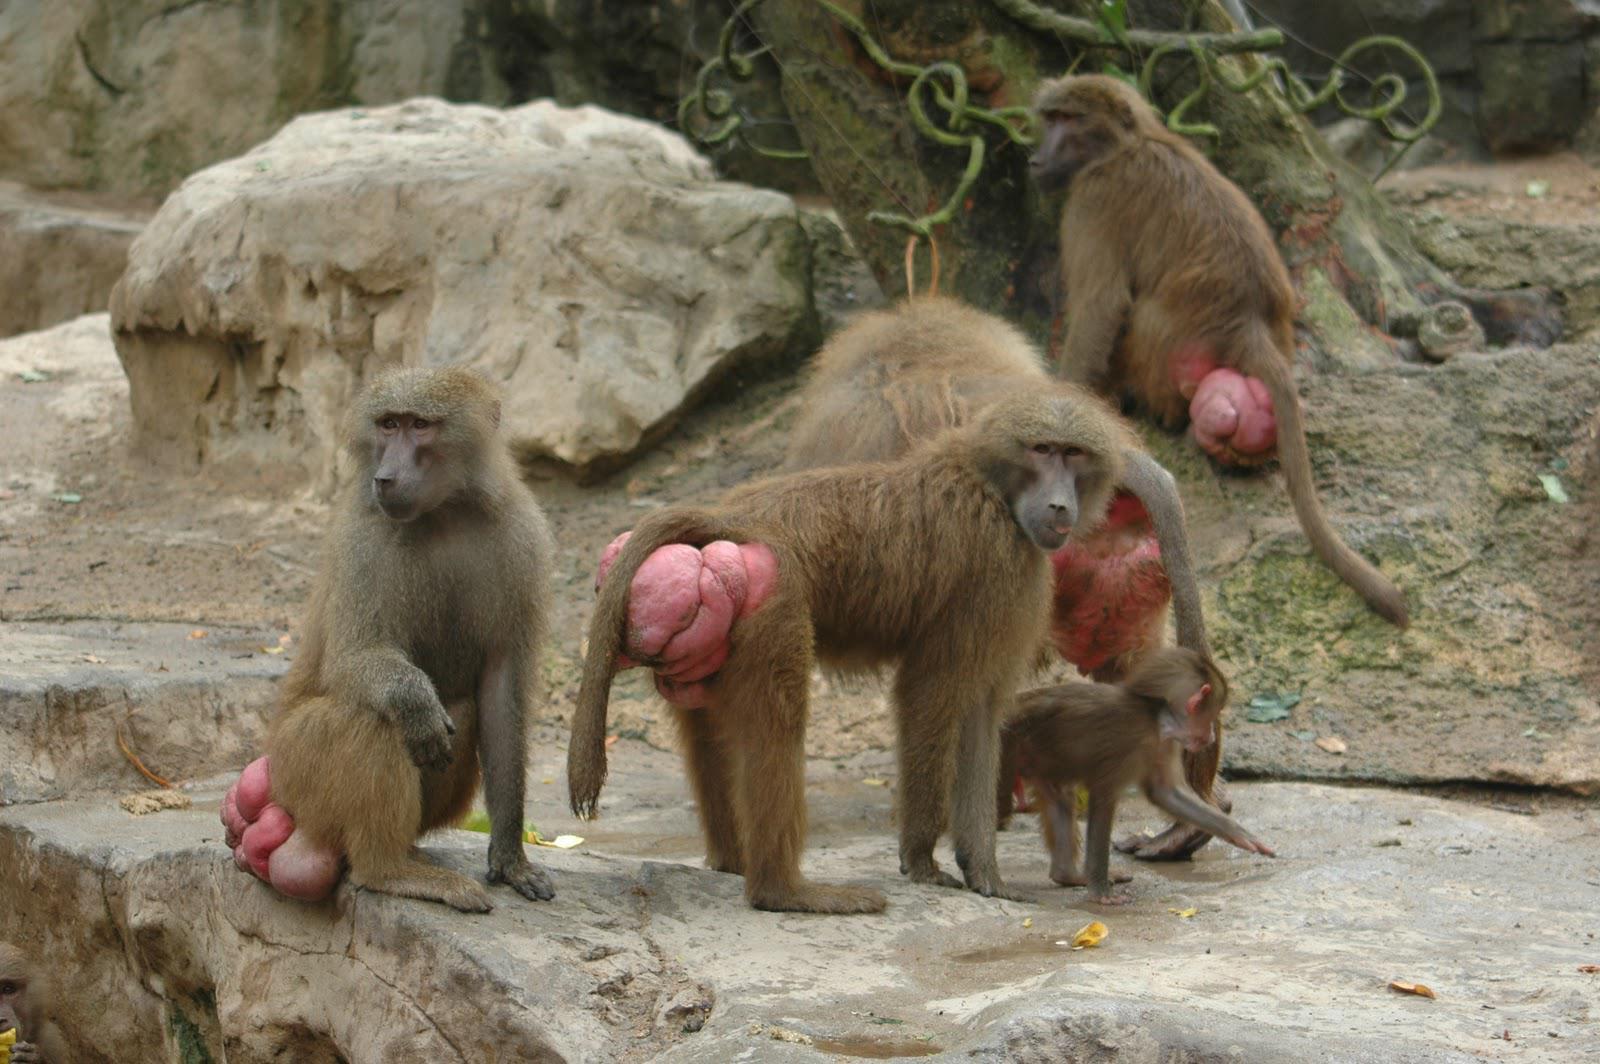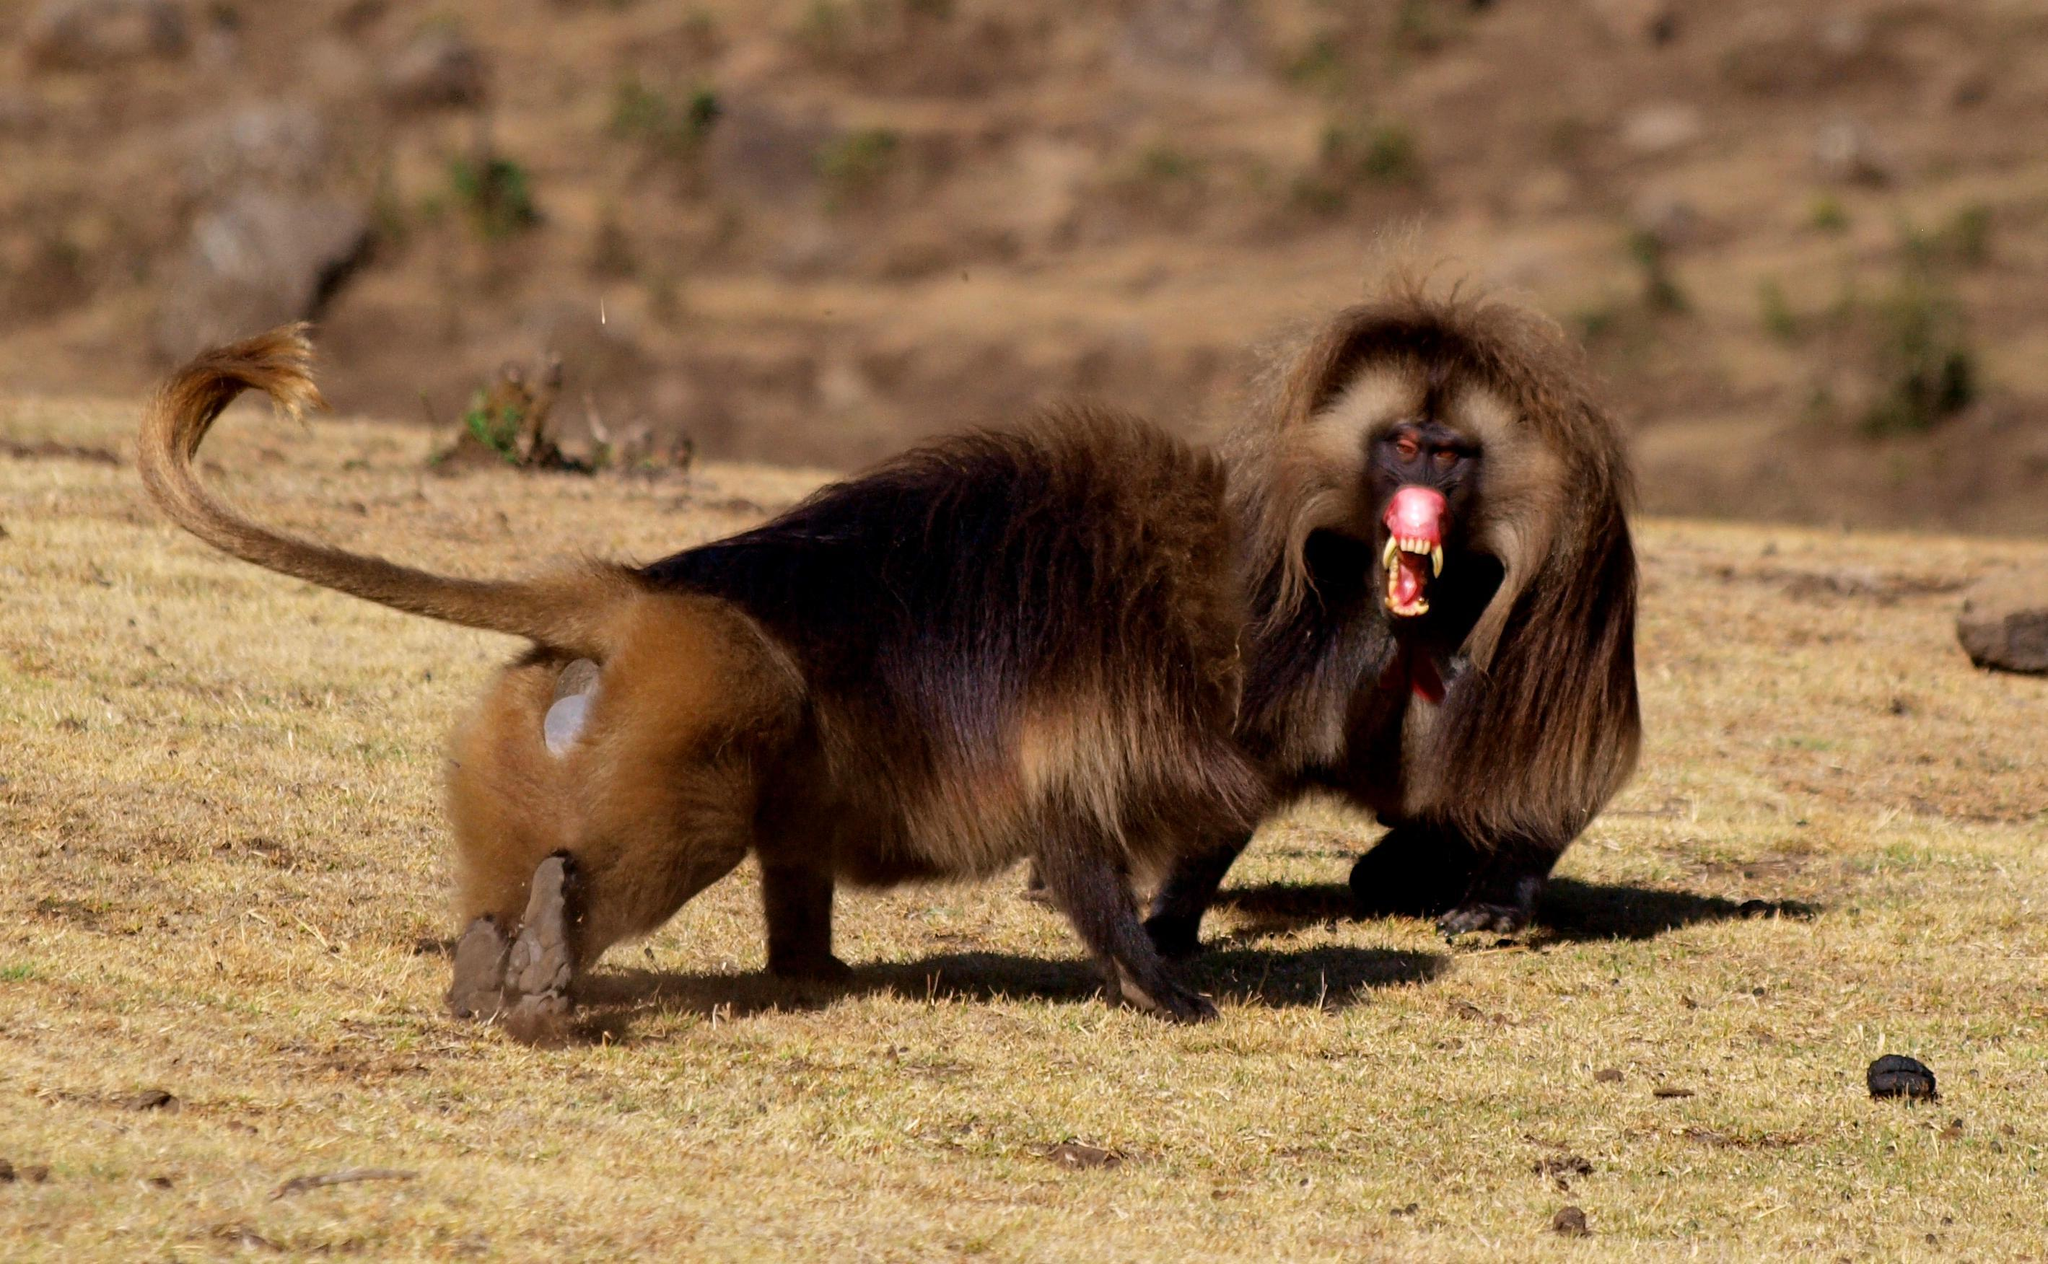The first image is the image on the left, the second image is the image on the right. Analyze the images presented: Is the assertion "A forward-facing fang-baring monkey with a lion-like mane of hair is in an image containing two animals." valid? Answer yes or no. Yes. The first image is the image on the left, the second image is the image on the right. Assess this claim about the two images: "The right image contains exactly two primates.". Correct or not? Answer yes or no. Yes. 